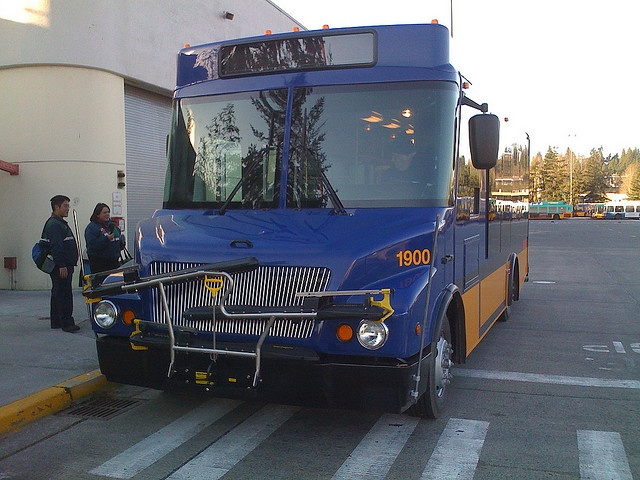Describe the objects in this image and their specific colors. I can see bus in white, black, gray, and navy tones, people in white, black, gray, maroon, and darkgray tones, people in white, black, navy, gray, and darkgray tones, people in white, gray, blue, and tan tones, and bus in white, teal, gray, darkgray, and black tones in this image. 